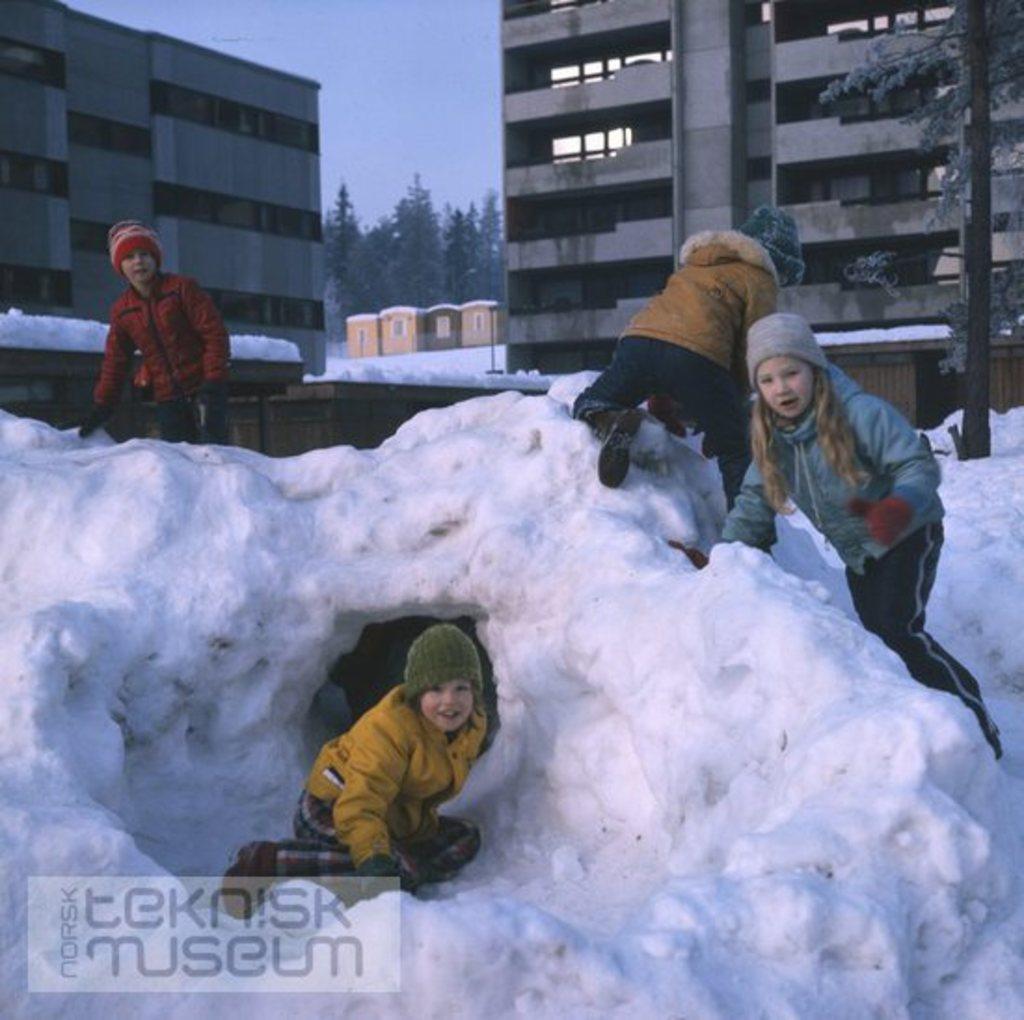Please provide a concise description of this image. This image is clicked outside. There is ice in the middle. There are some persons in the middle. They are children. There are buildings at the top. There are trees on the right side and middle. There is sky at the top. 